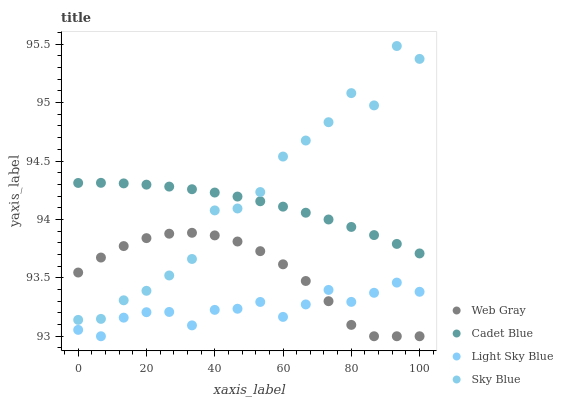Does Light Sky Blue have the minimum area under the curve?
Answer yes or no. Yes. Does Sky Blue have the maximum area under the curve?
Answer yes or no. Yes. Does Web Gray have the minimum area under the curve?
Answer yes or no. No. Does Web Gray have the maximum area under the curve?
Answer yes or no. No. Is Cadet Blue the smoothest?
Answer yes or no. Yes. Is Sky Blue the roughest?
Answer yes or no. Yes. Is Web Gray the smoothest?
Answer yes or no. No. Is Web Gray the roughest?
Answer yes or no. No. Does Web Gray have the lowest value?
Answer yes or no. Yes. Does Sky Blue have the lowest value?
Answer yes or no. No. Does Sky Blue have the highest value?
Answer yes or no. Yes. Does Web Gray have the highest value?
Answer yes or no. No. Is Web Gray less than Cadet Blue?
Answer yes or no. Yes. Is Sky Blue greater than Light Sky Blue?
Answer yes or no. Yes. Does Light Sky Blue intersect Web Gray?
Answer yes or no. Yes. Is Light Sky Blue less than Web Gray?
Answer yes or no. No. Is Light Sky Blue greater than Web Gray?
Answer yes or no. No. Does Web Gray intersect Cadet Blue?
Answer yes or no. No. 